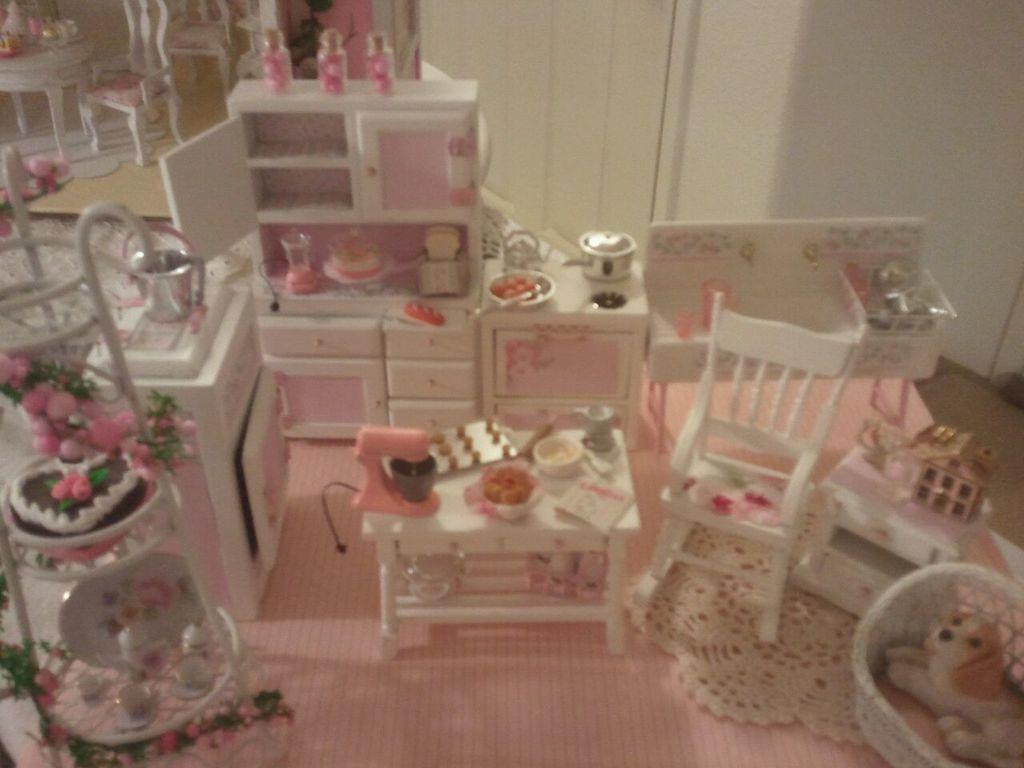What is the main structure visible in the image? There is a doll house in the image. What type of furniture can be seen in the image? There are chairs in the image. What is the purpose of the glass-enclosed structure in the image? There is a showcase in the image, which is typically used for displaying items. Can you describe any other items visible in the image? There are other items in the image, but their specific details are not mentioned in the provided facts. How many tomatoes are on the chairs in the image? There are no tomatoes mentioned or visible in the image. What type of ball is being used to play with the doll house in the image? There is no ball present or mentioned in the image. 